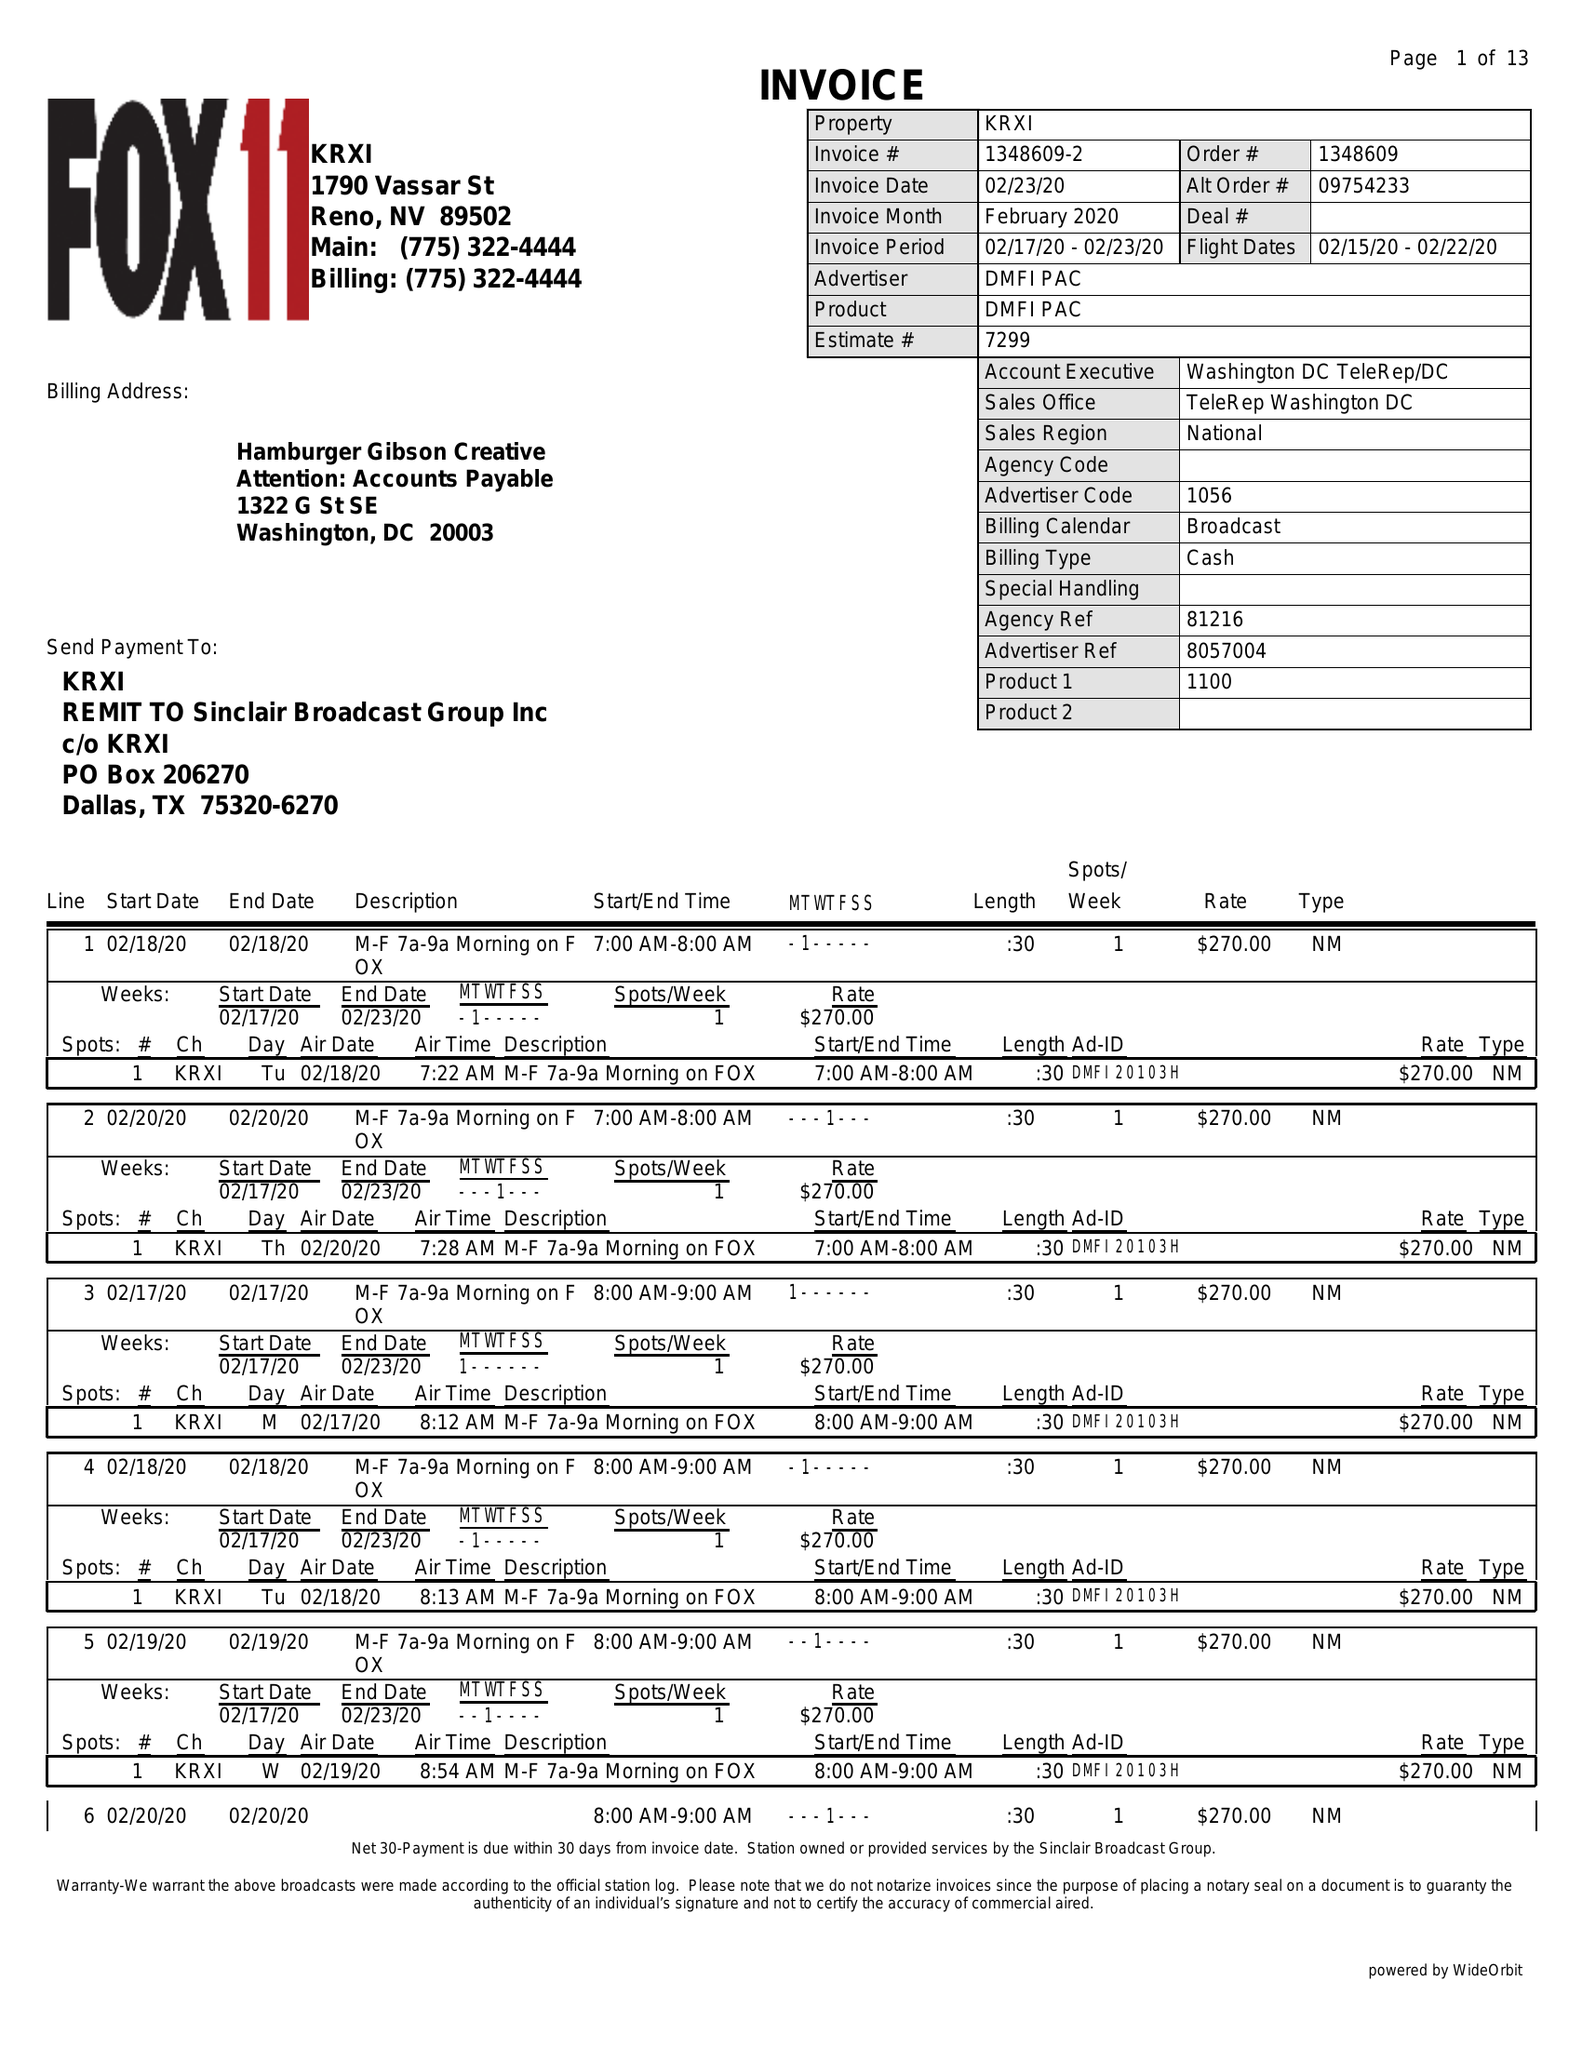What is the value for the gross_amount?
Answer the question using a single word or phrase. 22815.00 